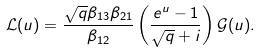<formula> <loc_0><loc_0><loc_500><loc_500>\mathcal { L } ( u ) = \frac { \sqrt { q } \beta _ { 1 3 } \beta _ { 2 1 } } { \beta _ { 1 2 } } \left ( \frac { e ^ { u } - 1 } { \sqrt { q } + i } \right ) \mathcal { G } ( u ) .</formula> 